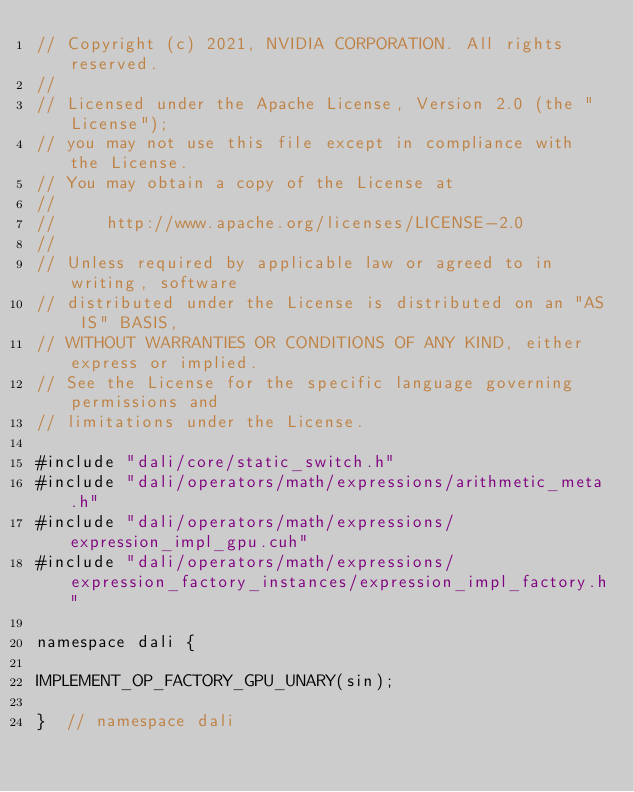<code> <loc_0><loc_0><loc_500><loc_500><_Cuda_>// Copyright (c) 2021, NVIDIA CORPORATION. All rights reserved.
//
// Licensed under the Apache License, Version 2.0 (the "License");
// you may not use this file except in compliance with the License.
// You may obtain a copy of the License at
//
//     http://www.apache.org/licenses/LICENSE-2.0
//
// Unless required by applicable law or agreed to in writing, software
// distributed under the License is distributed on an "AS IS" BASIS,
// WITHOUT WARRANTIES OR CONDITIONS OF ANY KIND, either express or implied.
// See the License for the specific language governing permissions and
// limitations under the License.

#include "dali/core/static_switch.h"
#include "dali/operators/math/expressions/arithmetic_meta.h"
#include "dali/operators/math/expressions/expression_impl_gpu.cuh"
#include "dali/operators/math/expressions/expression_factory_instances/expression_impl_factory.h"

namespace dali {

IMPLEMENT_OP_FACTORY_GPU_UNARY(sin);

}  // namespace dali
</code> 